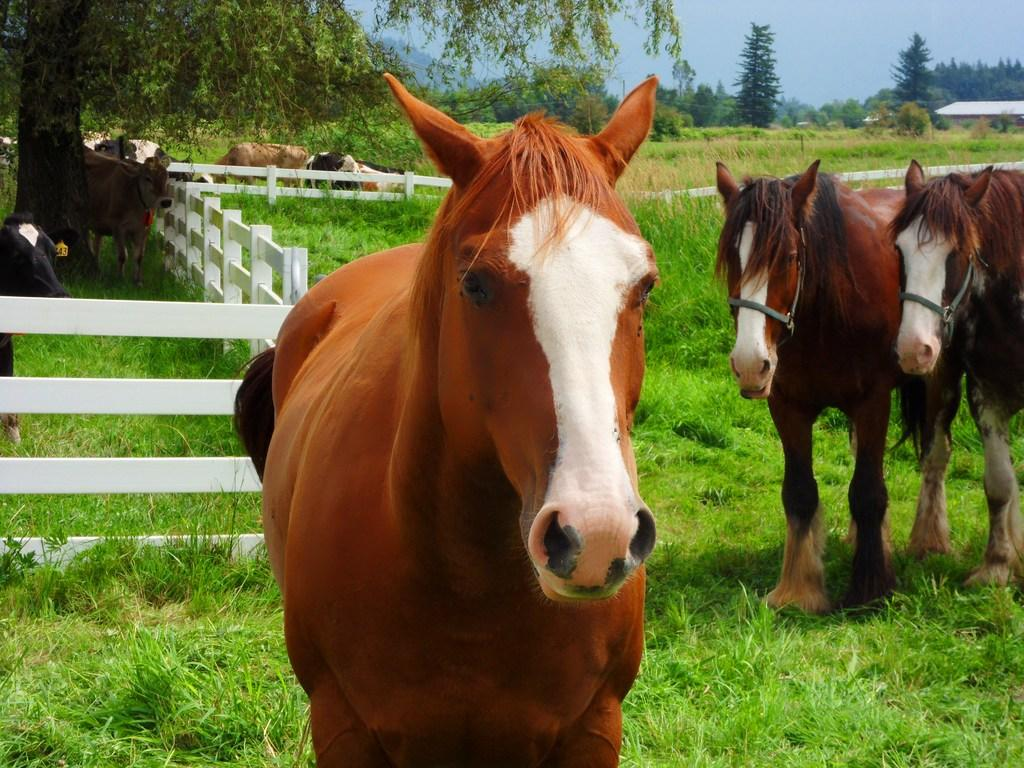What is the main subject of the image? There is a group of animals in the image. Where are the animals located? The animals are on the ground. What can be seen in the background of the image? There are trees, a fence, and the sky visible in the background of the image. What type of loaf is being used as a pillow by one of the animals in the image? There is no loaf present in the image, and the animals are not using any objects as pillows. 